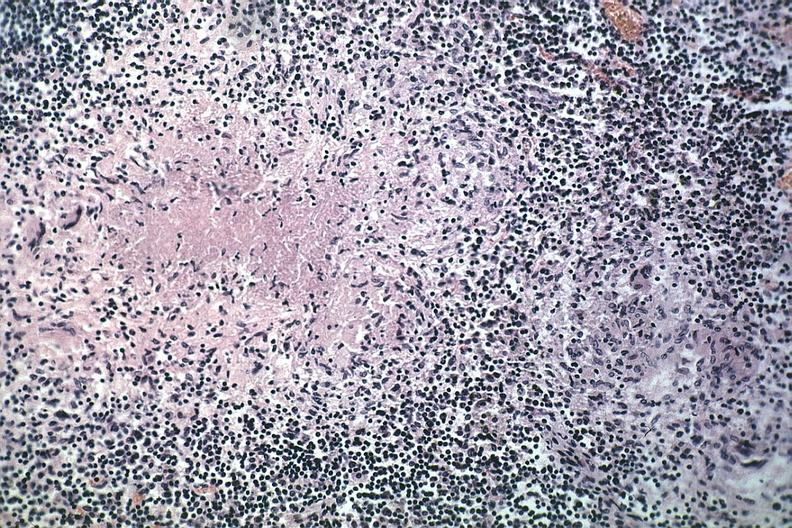what is present?
Answer the question using a single word or phrase. Tuberculosis 